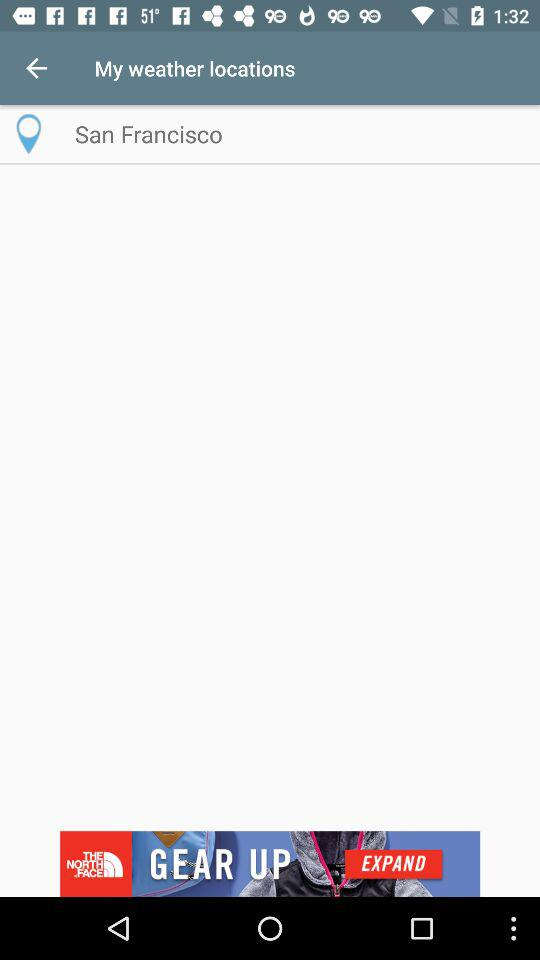What location is mentioned? The mentioned location is San Francisco. 